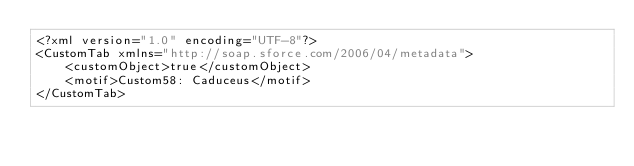<code> <loc_0><loc_0><loc_500><loc_500><_SQL_><?xml version="1.0" encoding="UTF-8"?>
<CustomTab xmlns="http://soap.sforce.com/2006/04/metadata">
    <customObject>true</customObject>
    <motif>Custom58: Caduceus</motif>
</CustomTab>
</code> 